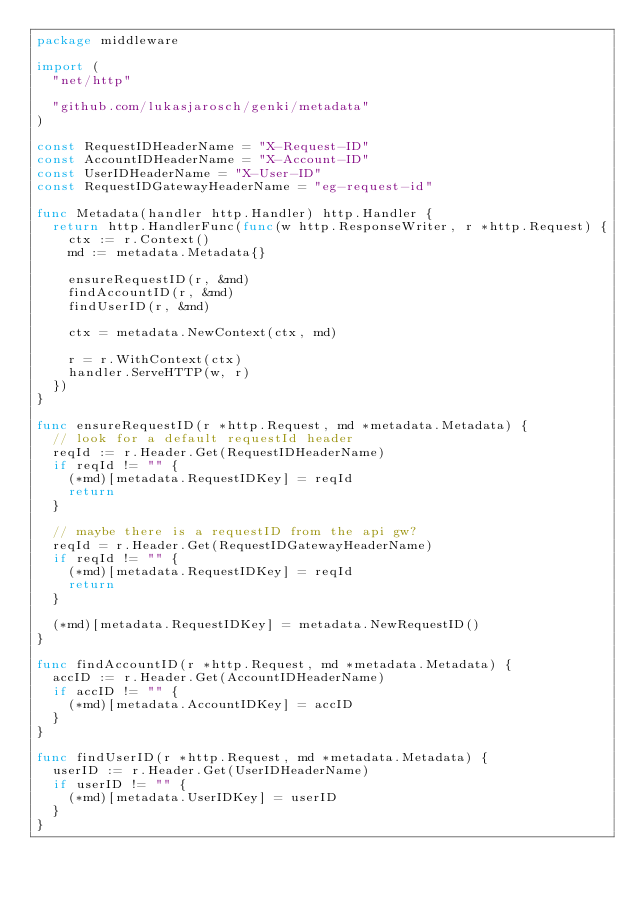<code> <loc_0><loc_0><loc_500><loc_500><_Go_>package middleware

import (
	"net/http"

	"github.com/lukasjarosch/genki/metadata"
)

const RequestIDHeaderName = "X-Request-ID"
const AccountIDHeaderName = "X-Account-ID"
const UserIDHeaderName = "X-User-ID"
const RequestIDGatewayHeaderName = "eg-request-id"

func Metadata(handler http.Handler) http.Handler {
	return http.HandlerFunc(func(w http.ResponseWriter, r *http.Request) {
		ctx := r.Context()
		md := metadata.Metadata{}

		ensureRequestID(r, &md)
		findAccountID(r, &md)
		findUserID(r, &md)

		ctx = metadata.NewContext(ctx, md)

		r = r.WithContext(ctx)
		handler.ServeHTTP(w, r)
	})
}

func ensureRequestID(r *http.Request, md *metadata.Metadata) {
	// look for a default requestId header
	reqId := r.Header.Get(RequestIDHeaderName)
	if reqId != "" {
		(*md)[metadata.RequestIDKey] = reqId
		return
	}

	// maybe there is a requestID from the api gw?
	reqId = r.Header.Get(RequestIDGatewayHeaderName)
	if reqId != "" {
		(*md)[metadata.RequestIDKey] = reqId
		return
	}

	(*md)[metadata.RequestIDKey] = metadata.NewRequestID()
}

func findAccountID(r *http.Request, md *metadata.Metadata) {
	accID := r.Header.Get(AccountIDHeaderName)
	if accID != "" {
		(*md)[metadata.AccountIDKey] = accID
	}
}

func findUserID(r *http.Request, md *metadata.Metadata) {
	userID := r.Header.Get(UserIDHeaderName)
	if userID != "" {
		(*md)[metadata.UserIDKey] = userID
	}
}
</code> 